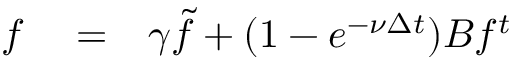<formula> <loc_0><loc_0><loc_500><loc_500>\begin{array} { r l r } { f } & = } & { \gamma \widetilde { f } + ( 1 - e ^ { - \nu \Delta t } ) B f ^ { t } } \end{array}</formula> 